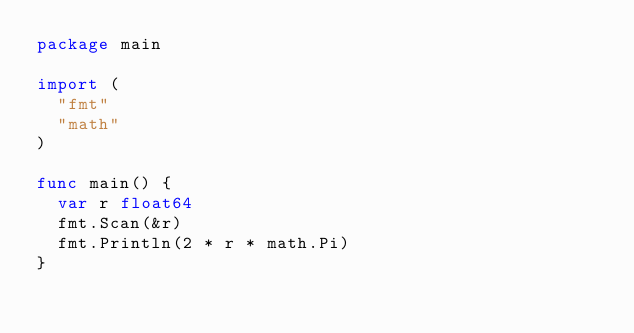Convert code to text. <code><loc_0><loc_0><loc_500><loc_500><_Go_>package main

import (
	"fmt"
	"math"
)

func main() {
	var r float64
	fmt.Scan(&r)
	fmt.Println(2 * r * math.Pi)
}</code> 